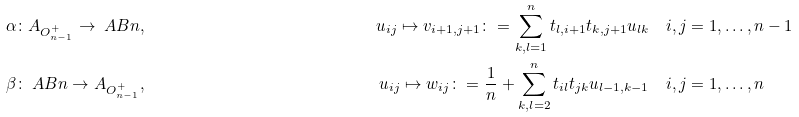Convert formula to latex. <formula><loc_0><loc_0><loc_500><loc_500>& \alpha \colon A _ { O _ { n - 1 } ^ { + } } \to \ A B n , \quad & u _ { i j } \mapsto v _ { i + 1 , j + 1 } \colon = \sum _ { k , l = 1 } ^ { n } t _ { l , i + 1 } t _ { k , j + 1 } u _ { l k } \quad & i , j = 1 , \dots , n - 1 \\ & \beta \colon \ A B n \to A _ { O _ { n - 1 } ^ { + } } , \quad & u _ { i j } \mapsto w _ { i j } \colon = \frac { 1 } { n } + \sum _ { k , l = 2 } ^ { n } t _ { i l } t _ { j k } u _ { l - 1 , k - 1 } \quad & i , j = 1 , \dots , n</formula> 